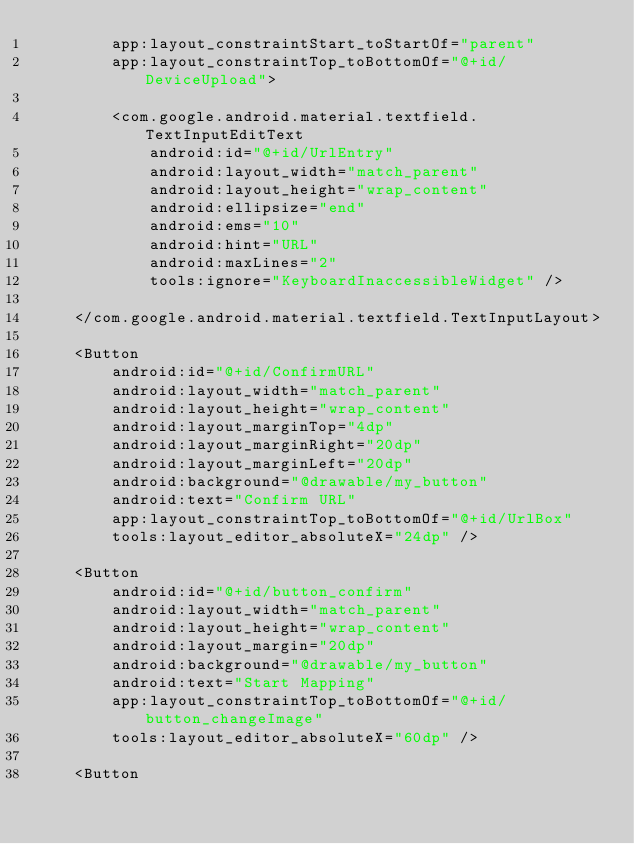Convert code to text. <code><loc_0><loc_0><loc_500><loc_500><_XML_>        app:layout_constraintStart_toStartOf="parent"
        app:layout_constraintTop_toBottomOf="@+id/DeviceUpload">

        <com.google.android.material.textfield.TextInputEditText
            android:id="@+id/UrlEntry"
            android:layout_width="match_parent"
            android:layout_height="wrap_content"
            android:ellipsize="end"
            android:ems="10"
            android:hint="URL"
            android:maxLines="2"
            tools:ignore="KeyboardInaccessibleWidget" />

    </com.google.android.material.textfield.TextInputLayout>

    <Button
        android:id="@+id/ConfirmURL"
        android:layout_width="match_parent"
        android:layout_height="wrap_content"
        android:layout_marginTop="4dp"
        android:layout_marginRight="20dp"
        android:layout_marginLeft="20dp"
        android:background="@drawable/my_button"
        android:text="Confirm URL"
        app:layout_constraintTop_toBottomOf="@+id/UrlBox"
        tools:layout_editor_absoluteX="24dp" />

    <Button
        android:id="@+id/button_confirm"
        android:layout_width="match_parent"
        android:layout_height="wrap_content"
        android:layout_margin="20dp"
        android:background="@drawable/my_button"
        android:text="Start Mapping"
        app:layout_constraintTop_toBottomOf="@+id/button_changeImage"
        tools:layout_editor_absoluteX="60dp" />

    <Button</code> 